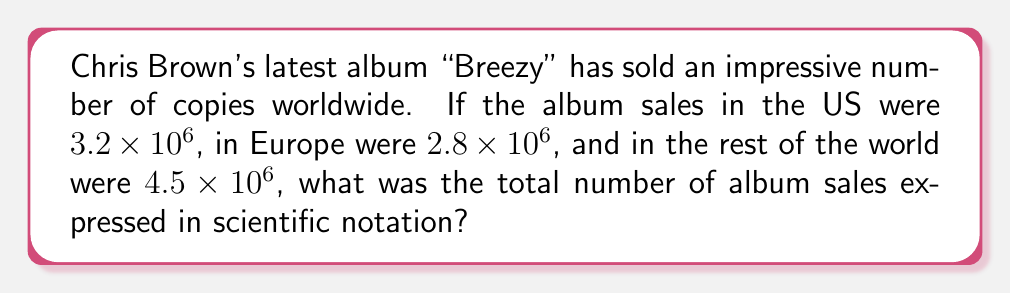Could you help me with this problem? To solve this problem, we need to add the sales figures from different regions and express the result in scientific notation. Let's break it down step-by-step:

1. US sales: $3.2 \times 10^6$
2. Europe sales: $2.8 \times 10^6$
3. Rest of the world sales: $4.5 \times 10^6$

To add these numbers, we can simply add the coefficients since they all have the same power of 10:

$$(3.2 \times 10^6) + (2.8 \times 10^6) + (4.5 \times 10^6)$$

$$ = (3.2 + 2.8 + 4.5) \times 10^6$$

$$ = 10.5 \times 10^6$$

Now, to express this in proper scientific notation, we need to adjust the coefficient to be between 1 and 10:

$$ 10.5 \times 10^6 = 1.05 \times 10^7$$

We moved the decimal point one place to the left in the coefficient (10.5 to 1.05) and increased the exponent by 1 (from 6 to 7) to compensate.
Answer: $1.05 \times 10^7$ 